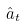<formula> <loc_0><loc_0><loc_500><loc_500>\hat { a } _ { t }</formula> 